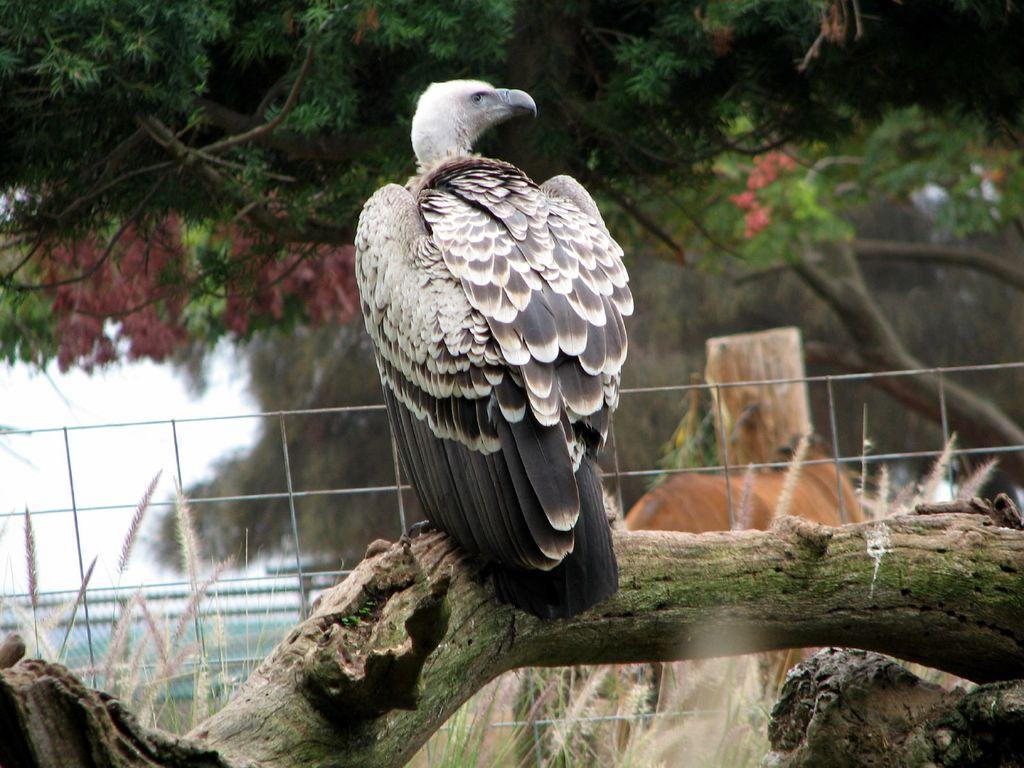How would you summarize this image in a sentence or two? There is a bird on the bark of a tree as we can see in the middle of this image. There are trees in the background. 